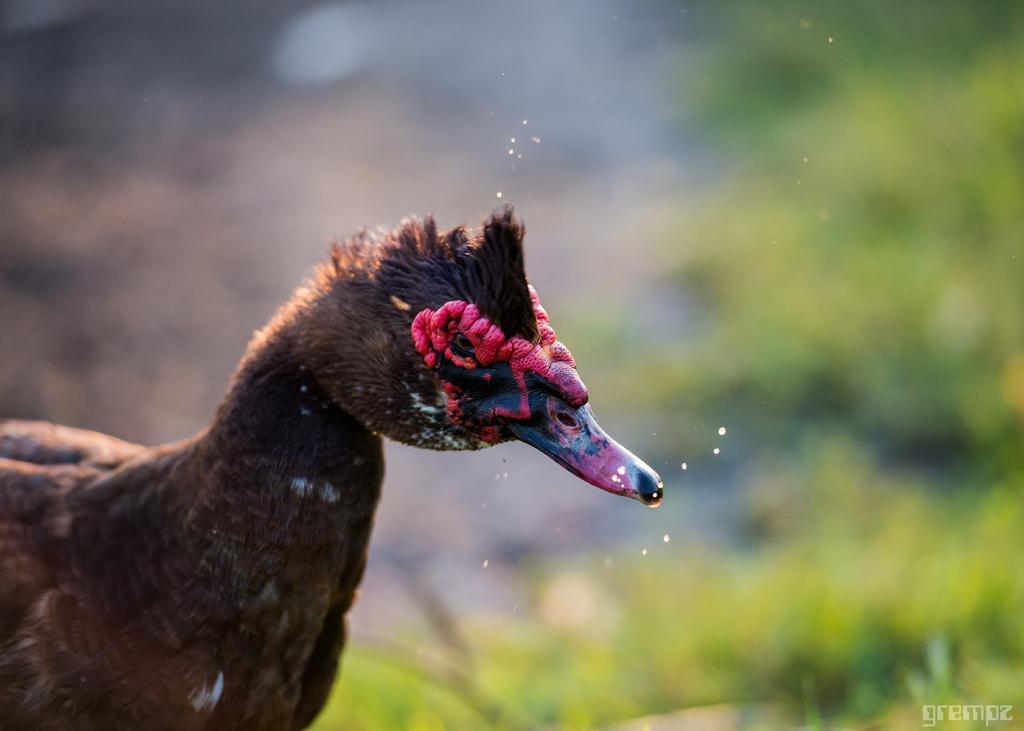Can you describe this image briefly? In the foreground of this image, on the left, there is a duck and the background image is blurred. 